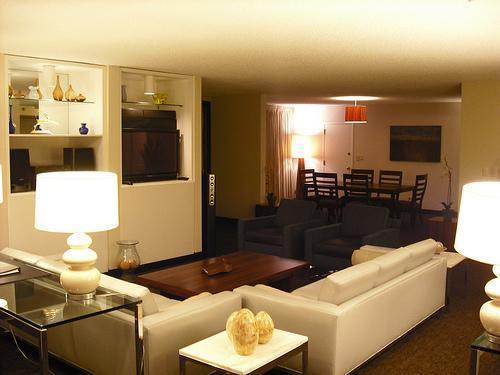How many couches are there?
Give a very brief answer. 2. 